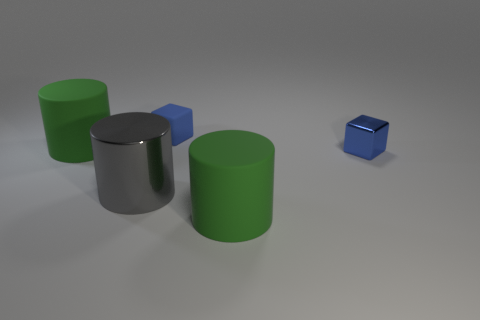Subtract all large metal cylinders. How many cylinders are left? 2 Subtract all gray cylinders. How many cylinders are left? 2 Subtract all cylinders. How many objects are left? 2 Subtract 3 cylinders. How many cylinders are left? 0 Subtract all green balls. How many red cubes are left? 0 Subtract all large green cylinders. Subtract all small blue rubber things. How many objects are left? 2 Add 5 small blue metallic cubes. How many small blue metallic cubes are left? 6 Add 5 red metal spheres. How many red metal spheres exist? 5 Add 2 large red rubber balls. How many objects exist? 7 Subtract 0 brown cubes. How many objects are left? 5 